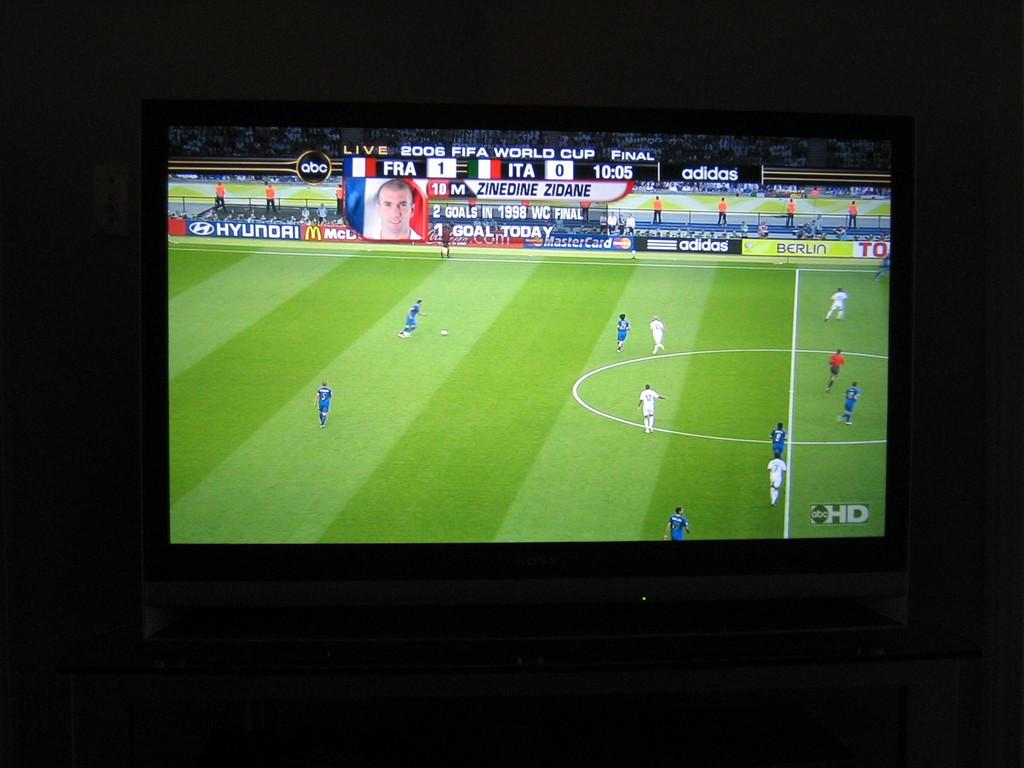Provide a one-sentence caption for the provided image. A tv that has the 2006 FIFA World Cup Final between France and Italy with a score of 1-0 respectively. 